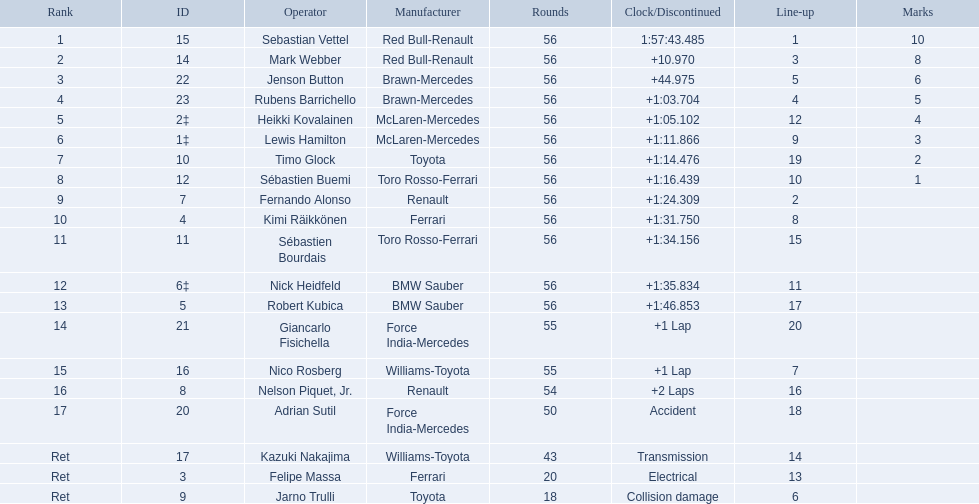Who were all the drivers? Sebastian Vettel, Mark Webber, Jenson Button, Rubens Barrichello, Heikki Kovalainen, Lewis Hamilton, Timo Glock, Sébastien Buemi, Fernando Alonso, Kimi Räikkönen, Sébastien Bourdais, Nick Heidfeld, Robert Kubica, Giancarlo Fisichella, Nico Rosberg, Nelson Piquet, Jr., Adrian Sutil, Kazuki Nakajima, Felipe Massa, Jarno Trulli. Which of these didn't have ferrari as a constructor? Sebastian Vettel, Mark Webber, Jenson Button, Rubens Barrichello, Heikki Kovalainen, Lewis Hamilton, Timo Glock, Sébastien Buemi, Fernando Alonso, Sébastien Bourdais, Nick Heidfeld, Robert Kubica, Giancarlo Fisichella, Nico Rosberg, Nelson Piquet, Jr., Adrian Sutil, Kazuki Nakajima, Jarno Trulli. Which of these was in first place? Sebastian Vettel. Who were the drivers at the 2009 chinese grand prix? Sebastian Vettel, Mark Webber, Jenson Button, Rubens Barrichello, Heikki Kovalainen, Lewis Hamilton, Timo Glock, Sébastien Buemi, Fernando Alonso, Kimi Räikkönen, Sébastien Bourdais, Nick Heidfeld, Robert Kubica, Giancarlo Fisichella, Nico Rosberg, Nelson Piquet, Jr., Adrian Sutil, Kazuki Nakajima, Felipe Massa, Jarno Trulli. Who had the slowest time? Robert Kubica. 